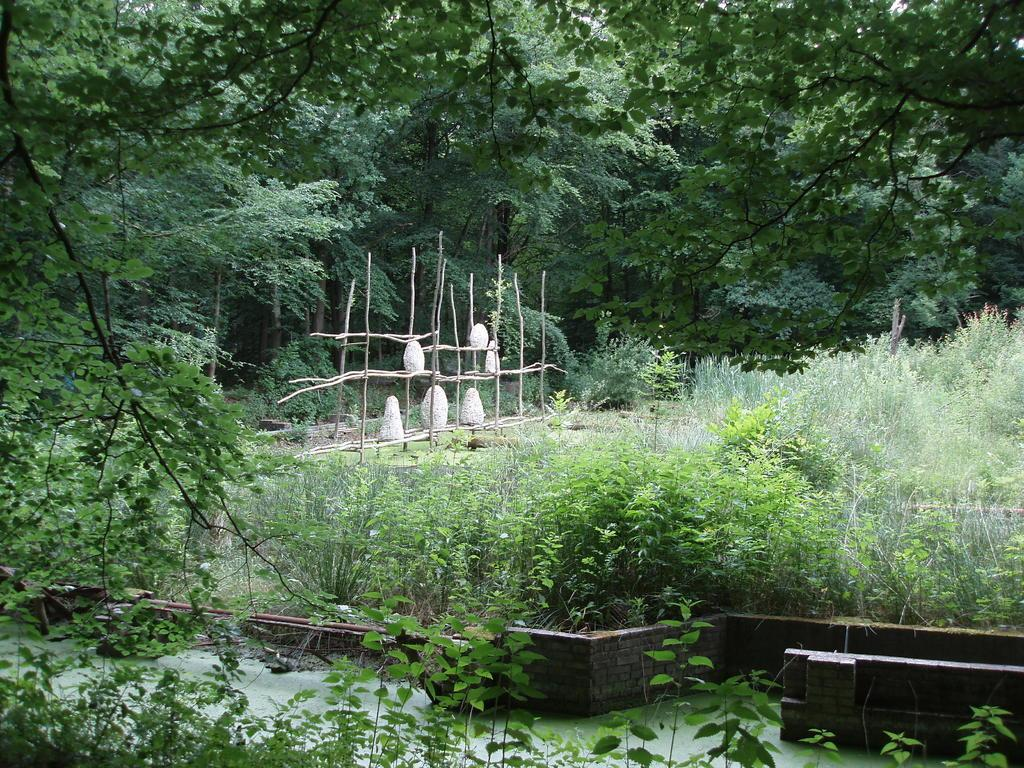What type of vegetation can be seen in the image? There are trees and plants in the image. What is present at the bottom of the image? There is water at the bottom of the image. What objects can be seen in the image that are made of wood? There are sticks visible in the image. What type of carpenter is working on the drawer in the image? There is no carpenter or drawer present in the image. 